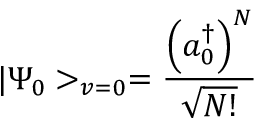Convert formula to latex. <formula><loc_0><loc_0><loc_500><loc_500>| \Psi _ { 0 } > _ { v = 0 } = \frac { \left ( a _ { 0 } ^ { \dagger } \right ) ^ { N } } { \sqrt { N ! } }</formula> 